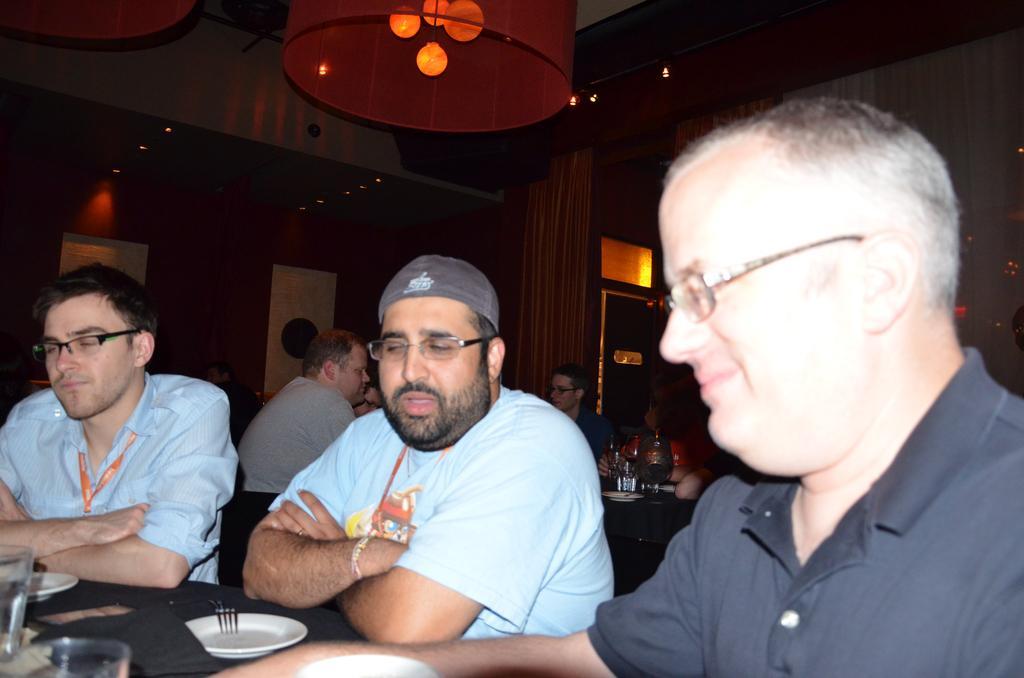In one or two sentences, can you explain what this image depicts? In this image I can see some people sitting around the table on which we can see some plates, spoons and other things. Also there is a chandelier hanging from the ceiling. 